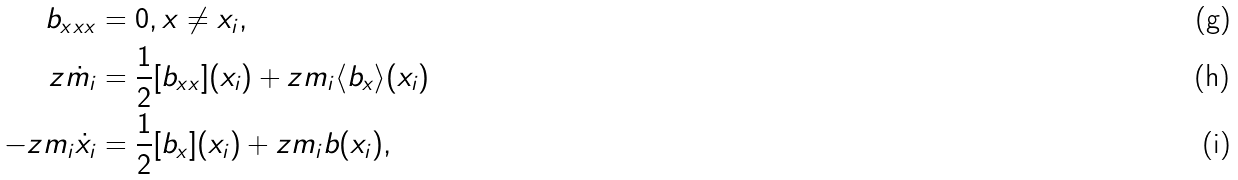<formula> <loc_0><loc_0><loc_500><loc_500>b _ { x x x } & = 0 , x \neq x _ { i } , \\ z \dot { m } _ { i } & = \frac { 1 } { 2 } [ b _ { x x } ] ( x _ { i } ) + z m _ { i } \langle b _ { x } \rangle ( x _ { i } ) \\ - z m _ { i } \dot { x } _ { i } & = \frac { 1 } { 2 } [ b _ { x } ] ( x _ { i } ) + z m _ { i } b ( x _ { i } ) ,</formula> 